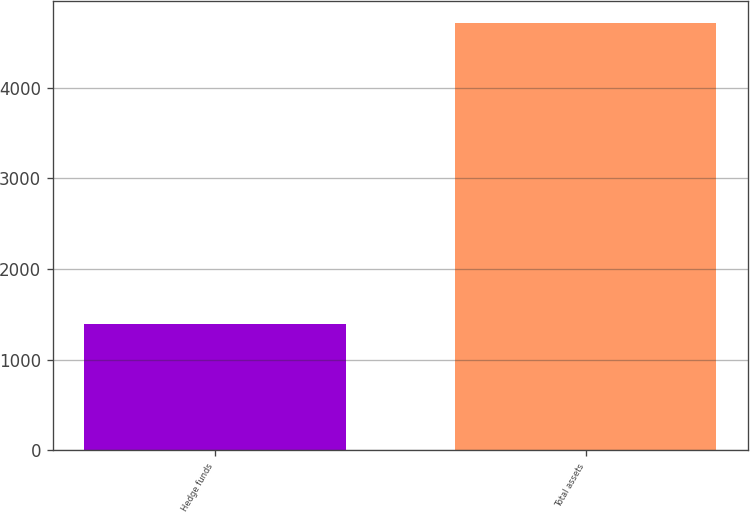Convert chart. <chart><loc_0><loc_0><loc_500><loc_500><bar_chart><fcel>Hedge funds<fcel>Total assets<nl><fcel>1390<fcel>4717<nl></chart> 